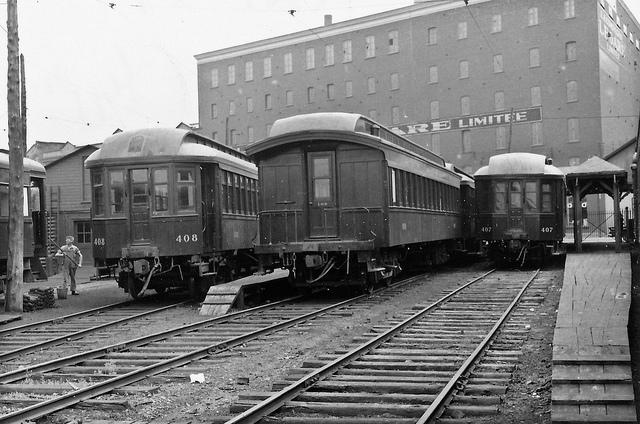What are the pants type the man is wearing? Please explain your reasoning. overalls. The man is wearing overalls. 